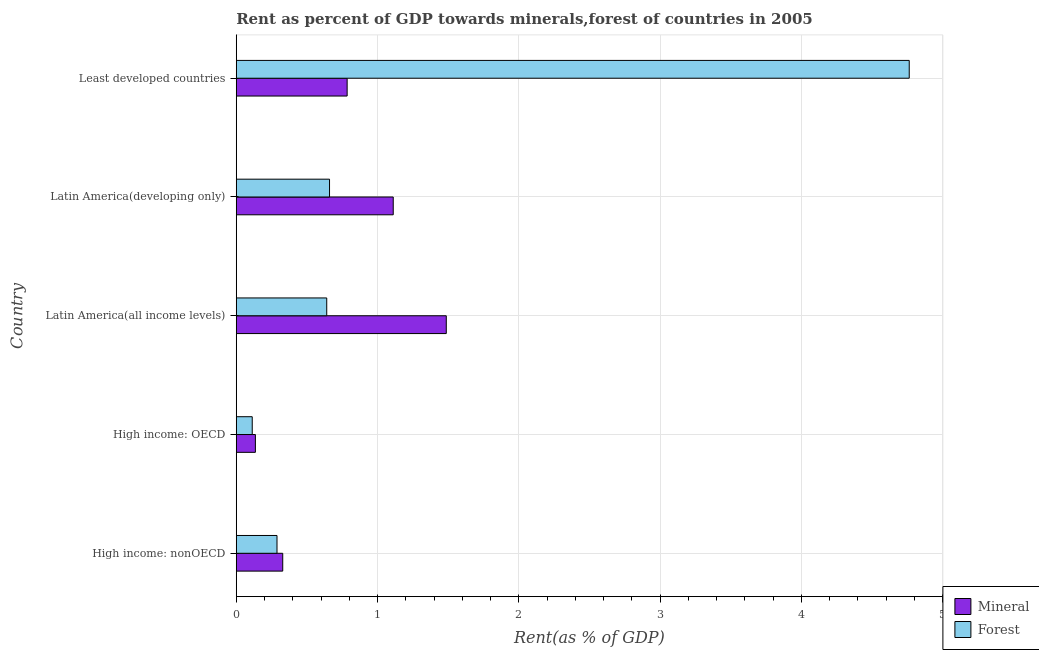How many groups of bars are there?
Your answer should be very brief. 5. Are the number of bars per tick equal to the number of legend labels?
Provide a succinct answer. Yes. Are the number of bars on each tick of the Y-axis equal?
Offer a very short reply. Yes. How many bars are there on the 1st tick from the top?
Give a very brief answer. 2. How many bars are there on the 5th tick from the bottom?
Your answer should be compact. 2. What is the label of the 4th group of bars from the top?
Make the answer very short. High income: OECD. What is the mineral rent in High income: OECD?
Your answer should be very brief. 0.14. Across all countries, what is the maximum mineral rent?
Keep it short and to the point. 1.49. Across all countries, what is the minimum mineral rent?
Your response must be concise. 0.14. In which country was the forest rent maximum?
Keep it short and to the point. Least developed countries. In which country was the mineral rent minimum?
Your answer should be very brief. High income: OECD. What is the total mineral rent in the graph?
Offer a terse response. 3.85. What is the difference between the forest rent in High income: nonOECD and that in Latin America(all income levels)?
Give a very brief answer. -0.35. What is the difference between the forest rent in Least developed countries and the mineral rent in Latin America(developing only)?
Keep it short and to the point. 3.65. What is the average forest rent per country?
Keep it short and to the point. 1.29. What is the difference between the forest rent and mineral rent in High income: nonOECD?
Give a very brief answer. -0.04. What is the ratio of the mineral rent in High income: OECD to that in Least developed countries?
Provide a succinct answer. 0.17. What is the difference between the highest and the second highest mineral rent?
Your answer should be compact. 0.38. What is the difference between the highest and the lowest forest rent?
Offer a terse response. 4.65. In how many countries, is the forest rent greater than the average forest rent taken over all countries?
Offer a terse response. 1. Is the sum of the mineral rent in Latin America(developing only) and Least developed countries greater than the maximum forest rent across all countries?
Your response must be concise. No. What does the 2nd bar from the top in High income: OECD represents?
Provide a short and direct response. Mineral. What does the 1st bar from the bottom in Latin America(developing only) represents?
Make the answer very short. Mineral. Are all the bars in the graph horizontal?
Make the answer very short. Yes. How many countries are there in the graph?
Ensure brevity in your answer.  5. What is the difference between two consecutive major ticks on the X-axis?
Offer a very short reply. 1. Does the graph contain any zero values?
Offer a very short reply. No. How many legend labels are there?
Give a very brief answer. 2. How are the legend labels stacked?
Offer a very short reply. Vertical. What is the title of the graph?
Your response must be concise. Rent as percent of GDP towards minerals,forest of countries in 2005. Does "Age 65(male)" appear as one of the legend labels in the graph?
Your answer should be very brief. No. What is the label or title of the X-axis?
Give a very brief answer. Rent(as % of GDP). What is the label or title of the Y-axis?
Ensure brevity in your answer.  Country. What is the Rent(as % of GDP) in Mineral in High income: nonOECD?
Offer a very short reply. 0.33. What is the Rent(as % of GDP) in Forest in High income: nonOECD?
Your response must be concise. 0.29. What is the Rent(as % of GDP) of Mineral in High income: OECD?
Ensure brevity in your answer.  0.14. What is the Rent(as % of GDP) of Forest in High income: OECD?
Your response must be concise. 0.11. What is the Rent(as % of GDP) in Mineral in Latin America(all income levels)?
Your answer should be very brief. 1.49. What is the Rent(as % of GDP) of Forest in Latin America(all income levels)?
Offer a terse response. 0.64. What is the Rent(as % of GDP) in Mineral in Latin America(developing only)?
Offer a terse response. 1.11. What is the Rent(as % of GDP) in Forest in Latin America(developing only)?
Offer a terse response. 0.66. What is the Rent(as % of GDP) in Mineral in Least developed countries?
Make the answer very short. 0.78. What is the Rent(as % of GDP) of Forest in Least developed countries?
Your answer should be compact. 4.76. Across all countries, what is the maximum Rent(as % of GDP) of Mineral?
Ensure brevity in your answer.  1.49. Across all countries, what is the maximum Rent(as % of GDP) of Forest?
Keep it short and to the point. 4.76. Across all countries, what is the minimum Rent(as % of GDP) of Mineral?
Your answer should be very brief. 0.14. Across all countries, what is the minimum Rent(as % of GDP) in Forest?
Provide a short and direct response. 0.11. What is the total Rent(as % of GDP) of Mineral in the graph?
Keep it short and to the point. 3.85. What is the total Rent(as % of GDP) of Forest in the graph?
Ensure brevity in your answer.  6.47. What is the difference between the Rent(as % of GDP) of Mineral in High income: nonOECD and that in High income: OECD?
Your answer should be compact. 0.19. What is the difference between the Rent(as % of GDP) of Forest in High income: nonOECD and that in High income: OECD?
Provide a succinct answer. 0.18. What is the difference between the Rent(as % of GDP) of Mineral in High income: nonOECD and that in Latin America(all income levels)?
Your answer should be very brief. -1.16. What is the difference between the Rent(as % of GDP) in Forest in High income: nonOECD and that in Latin America(all income levels)?
Your answer should be very brief. -0.35. What is the difference between the Rent(as % of GDP) in Mineral in High income: nonOECD and that in Latin America(developing only)?
Provide a succinct answer. -0.78. What is the difference between the Rent(as % of GDP) of Forest in High income: nonOECD and that in Latin America(developing only)?
Make the answer very short. -0.37. What is the difference between the Rent(as % of GDP) of Mineral in High income: nonOECD and that in Least developed countries?
Provide a succinct answer. -0.46. What is the difference between the Rent(as % of GDP) in Forest in High income: nonOECD and that in Least developed countries?
Provide a succinct answer. -4.48. What is the difference between the Rent(as % of GDP) of Mineral in High income: OECD and that in Latin America(all income levels)?
Offer a very short reply. -1.35. What is the difference between the Rent(as % of GDP) of Forest in High income: OECD and that in Latin America(all income levels)?
Your answer should be compact. -0.53. What is the difference between the Rent(as % of GDP) of Mineral in High income: OECD and that in Latin America(developing only)?
Your answer should be compact. -0.98. What is the difference between the Rent(as % of GDP) in Forest in High income: OECD and that in Latin America(developing only)?
Ensure brevity in your answer.  -0.55. What is the difference between the Rent(as % of GDP) of Mineral in High income: OECD and that in Least developed countries?
Keep it short and to the point. -0.65. What is the difference between the Rent(as % of GDP) in Forest in High income: OECD and that in Least developed countries?
Make the answer very short. -4.65. What is the difference between the Rent(as % of GDP) of Mineral in Latin America(all income levels) and that in Latin America(developing only)?
Keep it short and to the point. 0.38. What is the difference between the Rent(as % of GDP) in Forest in Latin America(all income levels) and that in Latin America(developing only)?
Your answer should be very brief. -0.02. What is the difference between the Rent(as % of GDP) of Mineral in Latin America(all income levels) and that in Least developed countries?
Provide a succinct answer. 0.7. What is the difference between the Rent(as % of GDP) of Forest in Latin America(all income levels) and that in Least developed countries?
Your response must be concise. -4.12. What is the difference between the Rent(as % of GDP) in Mineral in Latin America(developing only) and that in Least developed countries?
Offer a very short reply. 0.33. What is the difference between the Rent(as % of GDP) in Forest in Latin America(developing only) and that in Least developed countries?
Ensure brevity in your answer.  -4.1. What is the difference between the Rent(as % of GDP) of Mineral in High income: nonOECD and the Rent(as % of GDP) of Forest in High income: OECD?
Give a very brief answer. 0.22. What is the difference between the Rent(as % of GDP) in Mineral in High income: nonOECD and the Rent(as % of GDP) in Forest in Latin America(all income levels)?
Provide a succinct answer. -0.31. What is the difference between the Rent(as % of GDP) in Mineral in High income: nonOECD and the Rent(as % of GDP) in Forest in Latin America(developing only)?
Keep it short and to the point. -0.33. What is the difference between the Rent(as % of GDP) in Mineral in High income: nonOECD and the Rent(as % of GDP) in Forest in Least developed countries?
Offer a terse response. -4.43. What is the difference between the Rent(as % of GDP) of Mineral in High income: OECD and the Rent(as % of GDP) of Forest in Latin America(all income levels)?
Keep it short and to the point. -0.51. What is the difference between the Rent(as % of GDP) in Mineral in High income: OECD and the Rent(as % of GDP) in Forest in Latin America(developing only)?
Ensure brevity in your answer.  -0.52. What is the difference between the Rent(as % of GDP) in Mineral in High income: OECD and the Rent(as % of GDP) in Forest in Least developed countries?
Offer a terse response. -4.63. What is the difference between the Rent(as % of GDP) of Mineral in Latin America(all income levels) and the Rent(as % of GDP) of Forest in Latin America(developing only)?
Your answer should be very brief. 0.83. What is the difference between the Rent(as % of GDP) in Mineral in Latin America(all income levels) and the Rent(as % of GDP) in Forest in Least developed countries?
Keep it short and to the point. -3.28. What is the difference between the Rent(as % of GDP) in Mineral in Latin America(developing only) and the Rent(as % of GDP) in Forest in Least developed countries?
Give a very brief answer. -3.65. What is the average Rent(as % of GDP) of Mineral per country?
Make the answer very short. 0.77. What is the average Rent(as % of GDP) in Forest per country?
Your answer should be compact. 1.29. What is the difference between the Rent(as % of GDP) of Mineral and Rent(as % of GDP) of Forest in High income: nonOECD?
Your response must be concise. 0.04. What is the difference between the Rent(as % of GDP) of Mineral and Rent(as % of GDP) of Forest in High income: OECD?
Your response must be concise. 0.02. What is the difference between the Rent(as % of GDP) of Mineral and Rent(as % of GDP) of Forest in Latin America(all income levels)?
Offer a very short reply. 0.85. What is the difference between the Rent(as % of GDP) of Mineral and Rent(as % of GDP) of Forest in Latin America(developing only)?
Provide a short and direct response. 0.45. What is the difference between the Rent(as % of GDP) in Mineral and Rent(as % of GDP) in Forest in Least developed countries?
Ensure brevity in your answer.  -3.98. What is the ratio of the Rent(as % of GDP) in Mineral in High income: nonOECD to that in High income: OECD?
Your response must be concise. 2.43. What is the ratio of the Rent(as % of GDP) of Forest in High income: nonOECD to that in High income: OECD?
Your answer should be very brief. 2.55. What is the ratio of the Rent(as % of GDP) of Mineral in High income: nonOECD to that in Latin America(all income levels)?
Make the answer very short. 0.22. What is the ratio of the Rent(as % of GDP) in Forest in High income: nonOECD to that in Latin America(all income levels)?
Your response must be concise. 0.45. What is the ratio of the Rent(as % of GDP) of Mineral in High income: nonOECD to that in Latin America(developing only)?
Your answer should be compact. 0.3. What is the ratio of the Rent(as % of GDP) of Forest in High income: nonOECD to that in Latin America(developing only)?
Keep it short and to the point. 0.44. What is the ratio of the Rent(as % of GDP) of Mineral in High income: nonOECD to that in Least developed countries?
Provide a succinct answer. 0.42. What is the ratio of the Rent(as % of GDP) of Forest in High income: nonOECD to that in Least developed countries?
Provide a short and direct response. 0.06. What is the ratio of the Rent(as % of GDP) of Mineral in High income: OECD to that in Latin America(all income levels)?
Offer a very short reply. 0.09. What is the ratio of the Rent(as % of GDP) in Forest in High income: OECD to that in Latin America(all income levels)?
Provide a succinct answer. 0.18. What is the ratio of the Rent(as % of GDP) in Mineral in High income: OECD to that in Latin America(developing only)?
Your answer should be compact. 0.12. What is the ratio of the Rent(as % of GDP) of Forest in High income: OECD to that in Latin America(developing only)?
Offer a very short reply. 0.17. What is the ratio of the Rent(as % of GDP) of Mineral in High income: OECD to that in Least developed countries?
Your response must be concise. 0.17. What is the ratio of the Rent(as % of GDP) of Forest in High income: OECD to that in Least developed countries?
Your answer should be compact. 0.02. What is the ratio of the Rent(as % of GDP) of Mineral in Latin America(all income levels) to that in Latin America(developing only)?
Provide a succinct answer. 1.34. What is the ratio of the Rent(as % of GDP) in Forest in Latin America(all income levels) to that in Latin America(developing only)?
Keep it short and to the point. 0.97. What is the ratio of the Rent(as % of GDP) in Mineral in Latin America(all income levels) to that in Least developed countries?
Provide a short and direct response. 1.89. What is the ratio of the Rent(as % of GDP) in Forest in Latin America(all income levels) to that in Least developed countries?
Give a very brief answer. 0.13. What is the ratio of the Rent(as % of GDP) of Mineral in Latin America(developing only) to that in Least developed countries?
Give a very brief answer. 1.42. What is the ratio of the Rent(as % of GDP) in Forest in Latin America(developing only) to that in Least developed countries?
Your answer should be compact. 0.14. What is the difference between the highest and the second highest Rent(as % of GDP) of Mineral?
Make the answer very short. 0.38. What is the difference between the highest and the second highest Rent(as % of GDP) of Forest?
Make the answer very short. 4.1. What is the difference between the highest and the lowest Rent(as % of GDP) of Mineral?
Give a very brief answer. 1.35. What is the difference between the highest and the lowest Rent(as % of GDP) of Forest?
Offer a terse response. 4.65. 